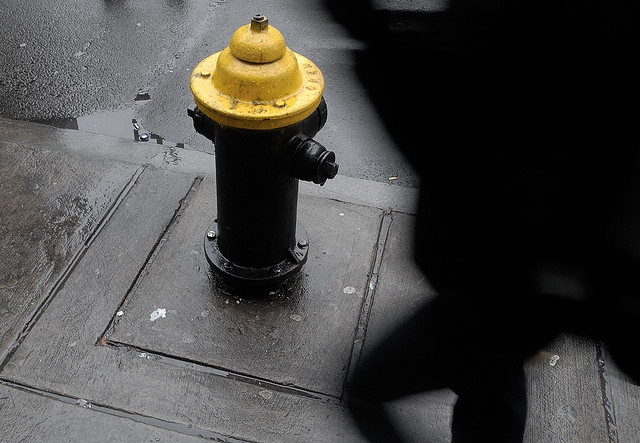Describe the objects in this image and their specific colors. I can see a fire hydrant in gray, black, khaki, olive, and gold tones in this image. 